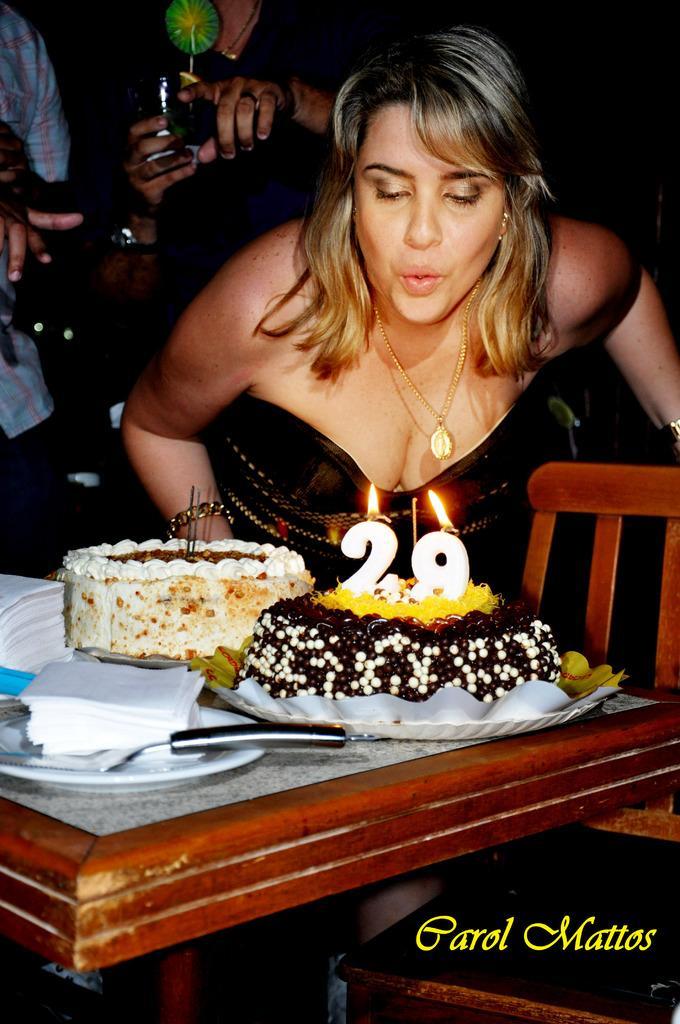In one or two sentences, can you explain what this image depicts? Here we can see a woman. This is table. On the table there are cakes, plate, tissue papers, and a knife. This is chair. In the background there are two persons. 